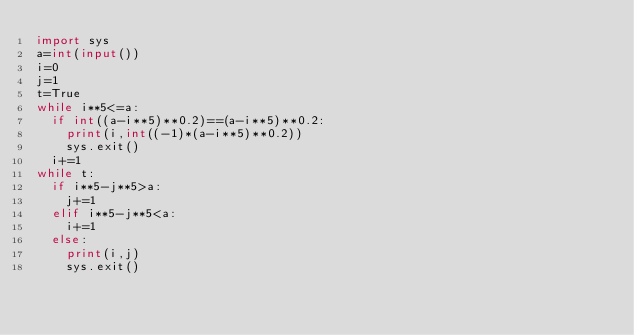Convert code to text. <code><loc_0><loc_0><loc_500><loc_500><_Python_>import sys
a=int(input())
i=0
j=1
t=True
while i**5<=a:
  if int((a-i**5)**0.2)==(a-i**5)**0.2:
    print(i,int((-1)*(a-i**5)**0.2))
    sys.exit()
  i+=1
while t:
  if i**5-j**5>a:
    j+=1
  elif i**5-j**5<a:
    i+=1
  else:
    print(i,j)
    sys.exit()</code> 